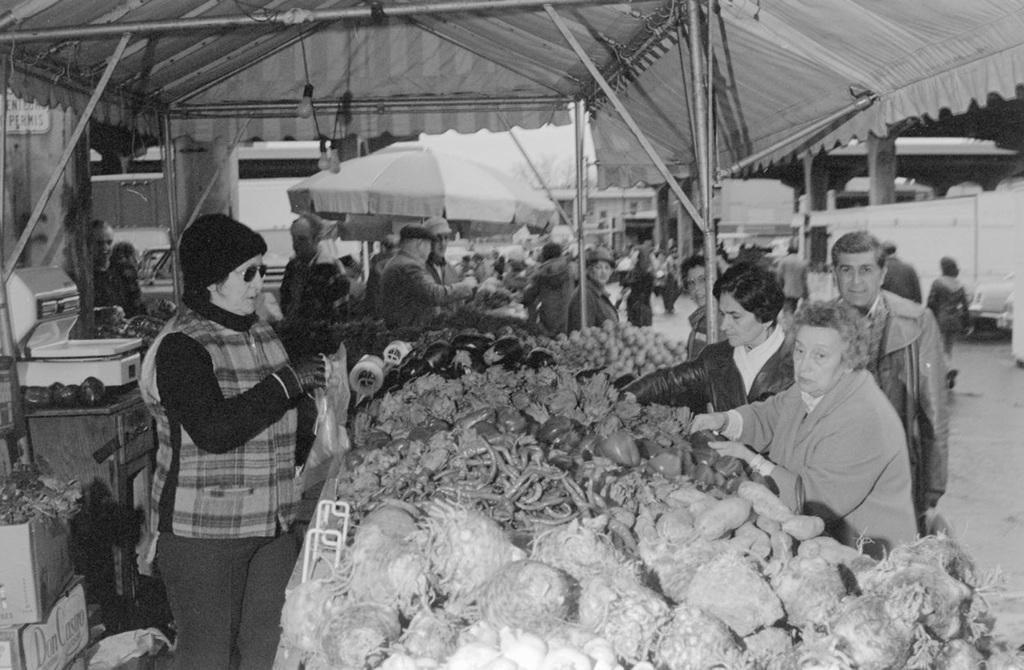In one or two sentences, can you explain what this image depicts? In this image I can see a crowd and different varieties of vegetables in the market. In the background I can see umbrella huts, shed, trees and the sky. This image is taken during a day near the market. 